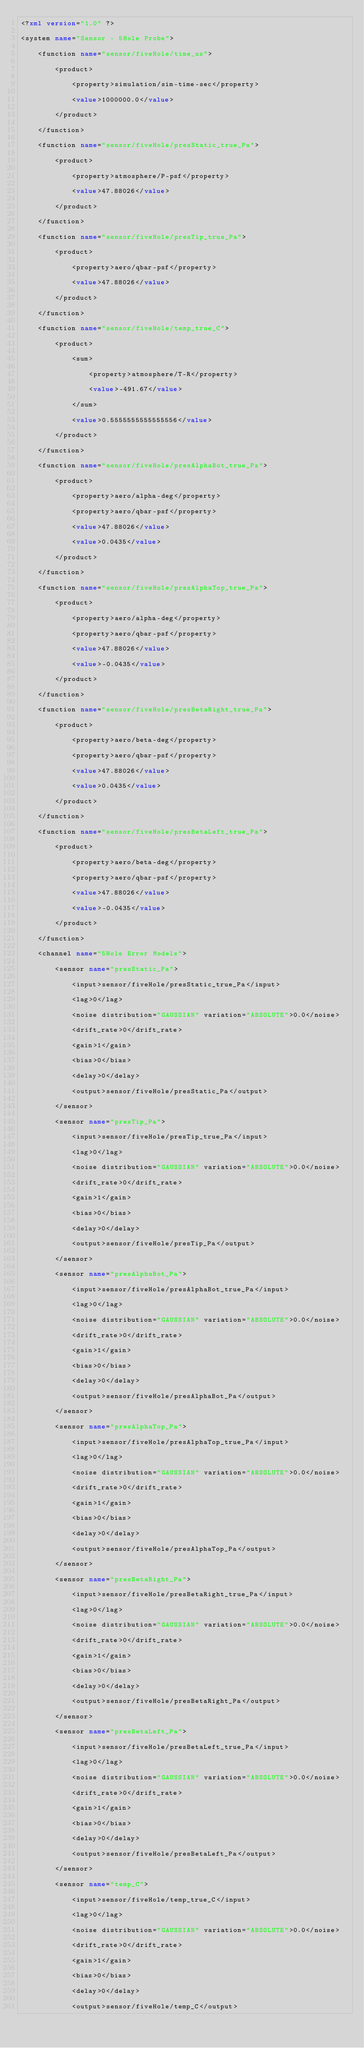<code> <loc_0><loc_0><loc_500><loc_500><_XML_><?xml version="1.0" ?>
<system name="Sensor - 5Hole Probe">
    <function name="sensor/fiveHole/time_us">
        <product>
            <property>simulation/sim-time-sec</property>
            <value>1000000.0</value>
        </product>
    </function>
    <function name="sensor/fiveHole/presStatic_true_Pa">
        <product>
            <property>atmosphere/P-psf</property>
            <value>47.88026</value>
        </product>
    </function>
    <function name="sensor/fiveHole/presTip_true_Pa">
        <product>
            <property>aero/qbar-psf</property>
            <value>47.88026</value>
        </product>
    </function>
    <function name="sensor/fiveHole/temp_true_C">
        <product>
            <sum>
                <property>atmosphere/T-R</property>
                <value>-491.67</value>
            </sum>
            <value>0.5555555555555556</value>
        </product>
    </function>
    <function name="sensor/fiveHole/presAlphaBot_true_Pa">
        <product>
            <property>aero/alpha-deg</property>
            <property>aero/qbar-psf</property>
            <value>47.88026</value>
            <value>0.0435</value>
        </product>
    </function>
    <function name="sensor/fiveHole/presAlphaTop_true_Pa">
        <product>
            <property>aero/alpha-deg</property>
            <property>aero/qbar-psf</property>
            <value>47.88026</value>
            <value>-0.0435</value>
        </product>
    </function>
    <function name="sensor/fiveHole/presBetaRight_true_Pa">
        <product>
            <property>aero/beta-deg</property>
            <property>aero/qbar-psf</property>
            <value>47.88026</value>
            <value>0.0435</value>
        </product>
    </function>
    <function name="sensor/fiveHole/presBetaLeft_true_Pa">
        <product>
            <property>aero/beta-deg</property>
            <property>aero/qbar-psf</property>
            <value>47.88026</value>
            <value>-0.0435</value>
        </product>
    </function>
    <channel name="5Hole Error Models">
        <sensor name="presStatic_Pa">
            <input>sensor/fiveHole/presStatic_true_Pa</input>
            <lag>0</lag>
            <noise distribution="GAUSSIAN" variation="ABSOLUTE">0.0</noise>
            <drift_rate>0</drift_rate>
            <gain>1</gain>
            <bias>0</bias>
            <delay>0</delay>
            <output>sensor/fiveHole/presStatic_Pa</output>
        </sensor>
        <sensor name="presTip_Pa">
            <input>sensor/fiveHole/presTip_true_Pa</input>
            <lag>0</lag>
            <noise distribution="GAUSSIAN" variation="ABSOLUTE">0.0</noise>
            <drift_rate>0</drift_rate>
            <gain>1</gain>
            <bias>0</bias>
            <delay>0</delay>
            <output>sensor/fiveHole/presTip_Pa</output>
        </sensor>
        <sensor name="presAlphaBot_Pa">
            <input>sensor/fiveHole/presAlphaBot_true_Pa</input>
            <lag>0</lag>
            <noise distribution="GAUSSIAN" variation="ABSOLUTE">0.0</noise>
            <drift_rate>0</drift_rate>
            <gain>1</gain>
            <bias>0</bias>
            <delay>0</delay>
            <output>sensor/fiveHole/presAlphaBot_Pa</output>
        </sensor>
        <sensor name="presAlphaTop_Pa">
            <input>sensor/fiveHole/presAlphaTop_true_Pa</input>
            <lag>0</lag>
            <noise distribution="GAUSSIAN" variation="ABSOLUTE">0.0</noise>
            <drift_rate>0</drift_rate>
            <gain>1</gain>
            <bias>0</bias>
            <delay>0</delay>
            <output>sensor/fiveHole/presAlphaTop_Pa</output>
        </sensor>
        <sensor name="presBetaRight_Pa">
            <input>sensor/fiveHole/presBetaRight_true_Pa</input>
            <lag>0</lag>
            <noise distribution="GAUSSIAN" variation="ABSOLUTE">0.0</noise>
            <drift_rate>0</drift_rate>
            <gain>1</gain>
            <bias>0</bias>
            <delay>0</delay>
            <output>sensor/fiveHole/presBetaRight_Pa</output>
        </sensor>
        <sensor name="presBetaLeft_Pa">
            <input>sensor/fiveHole/presBetaLeft_true_Pa</input>
            <lag>0</lag>
            <noise distribution="GAUSSIAN" variation="ABSOLUTE">0.0</noise>
            <drift_rate>0</drift_rate>
            <gain>1</gain>
            <bias>0</bias>
            <delay>0</delay>
            <output>sensor/fiveHole/presBetaLeft_Pa</output>
        </sensor>
        <sensor name="temp_C">
            <input>sensor/fiveHole/temp_true_C</input>
            <lag>0</lag>
            <noise distribution="GAUSSIAN" variation="ABSOLUTE">0.0</noise>
            <drift_rate>0</drift_rate>
            <gain>1</gain>
            <bias>0</bias>
            <delay>0</delay>
            <output>sensor/fiveHole/temp_C</output></code> 